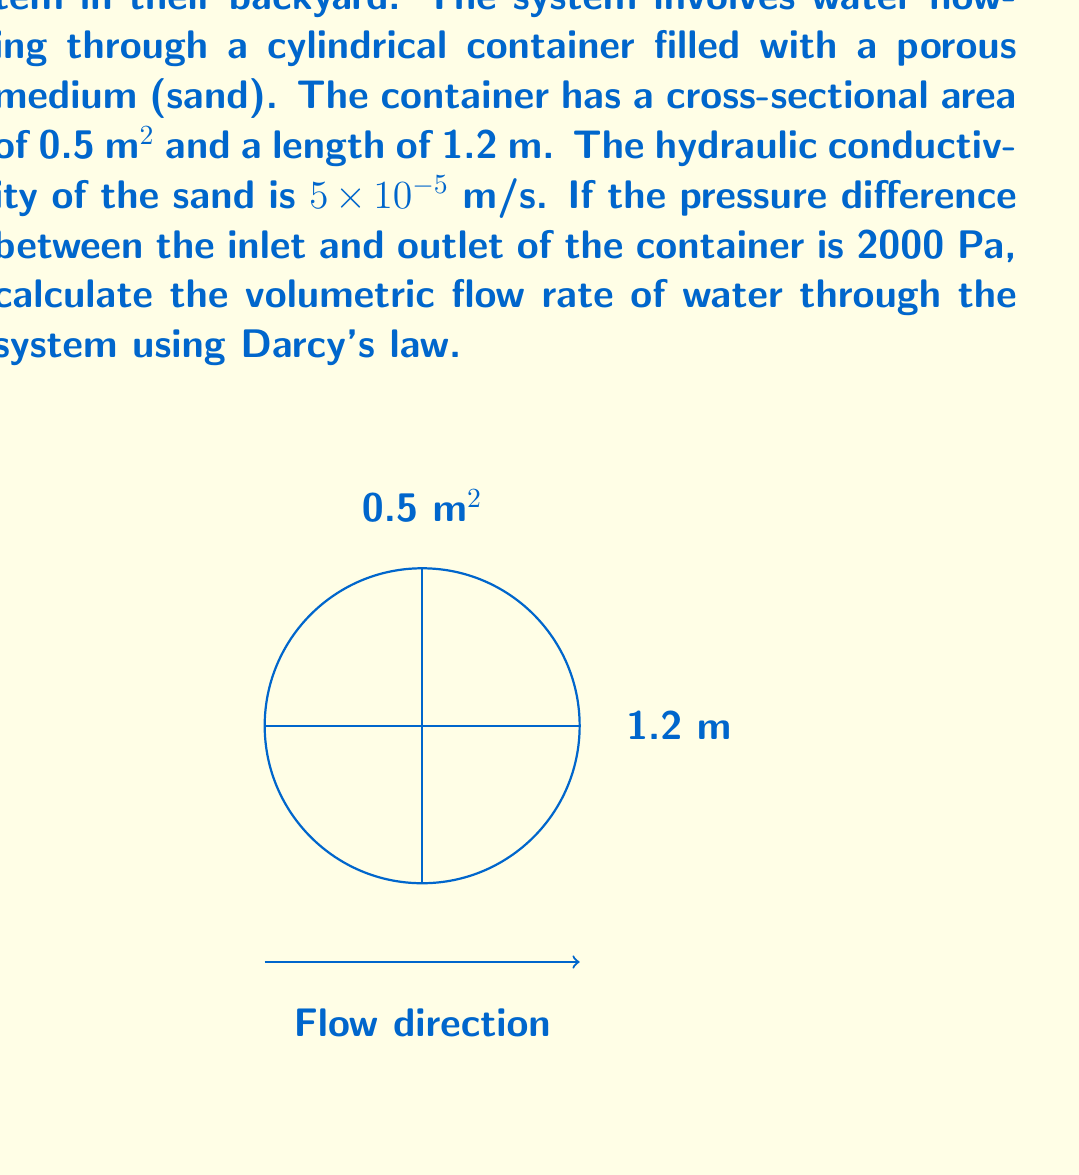Help me with this question. To solve this problem, we'll use Darcy's law, which describes the flow of fluids through porous media. The law states that:

$$Q = -K A \frac{dh}{dL}$$

Where:
$Q$ = volumetric flow rate (m³/s)
$K$ = hydraulic conductivity (m/s)
$A$ = cross-sectional area (m²)
$\frac{dh}{dL}$ = hydraulic gradient (dimensionless)

Given:
- Cross-sectional area, $A = 0.5$ m²
- Length of container, $L = 1.2$ m
- Hydraulic conductivity, $K = 5 \times 10^{-5}$ m/s
- Pressure difference, $\Delta P = 2000$ Pa

Step 1: Calculate the hydraulic gradient.
The hydraulic gradient is the change in hydraulic head over the length of the container. We can calculate it from the pressure difference:

$$\frac{dh}{dL} = \frac{\Delta P}{\rho g L}$$

Where $\rho$ is the density of water (1000 kg/m³) and $g$ is the acceleration due to gravity (9.81 m/s²).

$$\frac{dh}{dL} = \frac{2000}{1000 \times 9.81 \times 1.2} = 0.17$$

Step 2: Apply Darcy's law to calculate the volumetric flow rate.
Note that we remove the negative sign because we're given the pressure difference rather than the hydraulic head difference.

$$Q = K A \frac{dh}{dL}$$
$$Q = (5 \times 10^{-5}) \times 0.5 \times 0.17$$
$$Q = 4.25 \times 10^{-6}$$ m³/s

Step 3: Convert to a more practical unit (liters per minute).
$$Q = (4.25 \times 10^{-6}) \times (1000 \text{ L/m³}) \times (60 \text{ s/min}) = 0.255$$ L/min
Answer: 0.255 L/min 